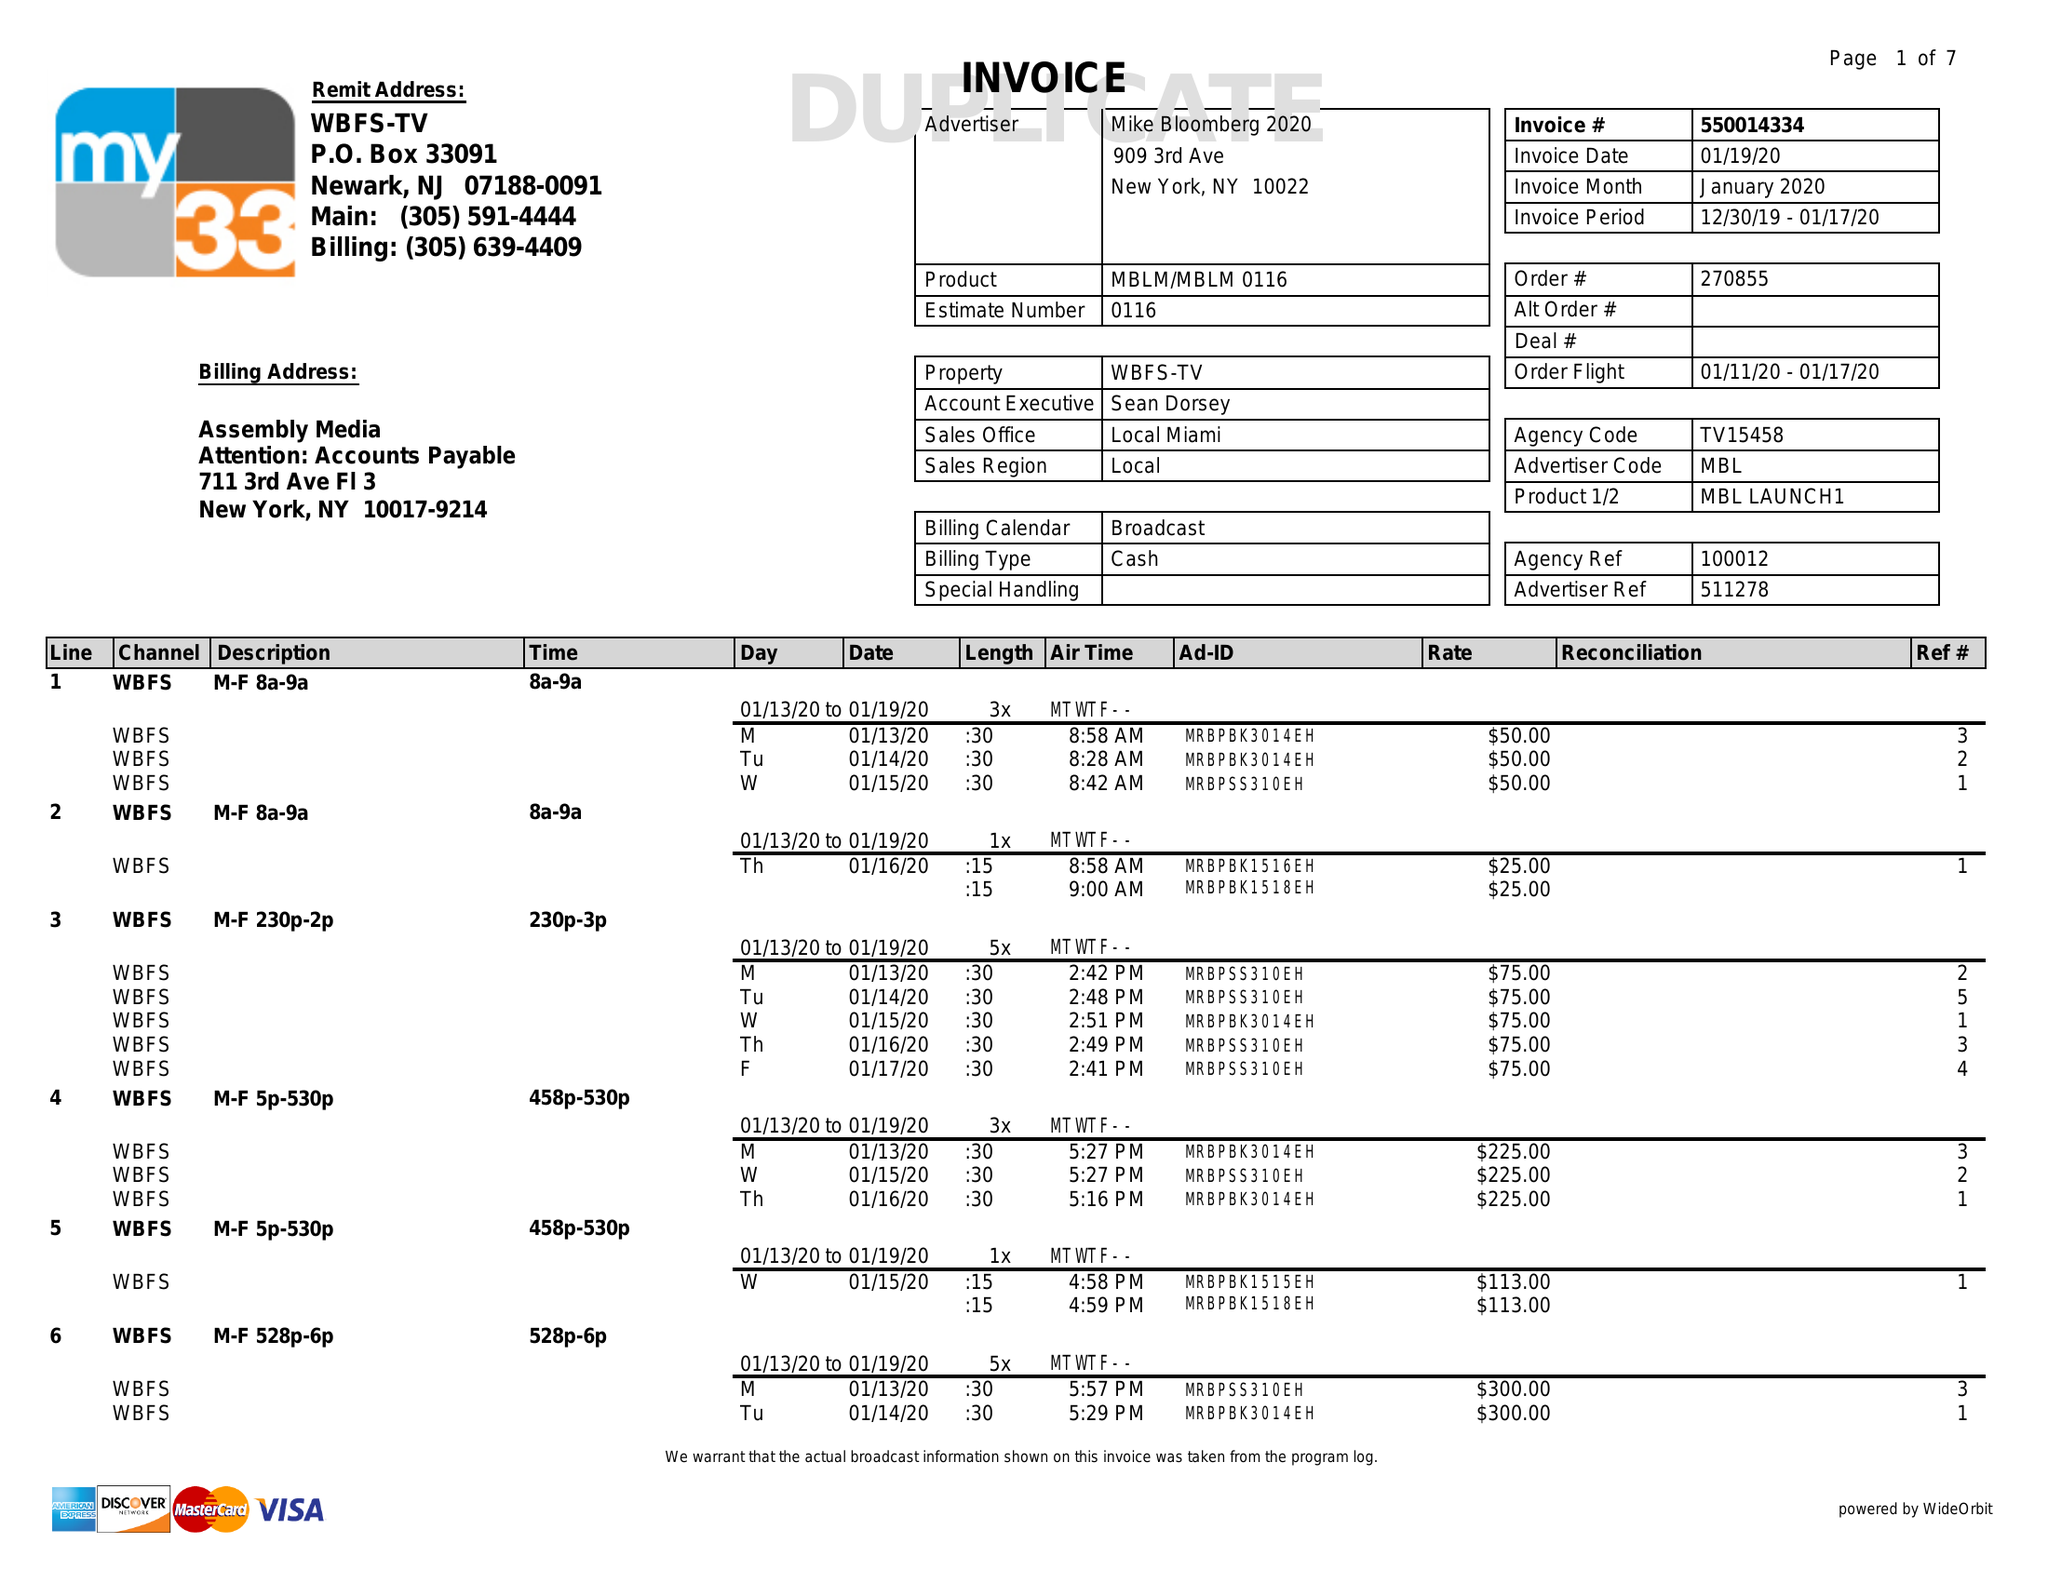What is the value for the gross_amount?
Answer the question using a single word or phrase. 19776.00 